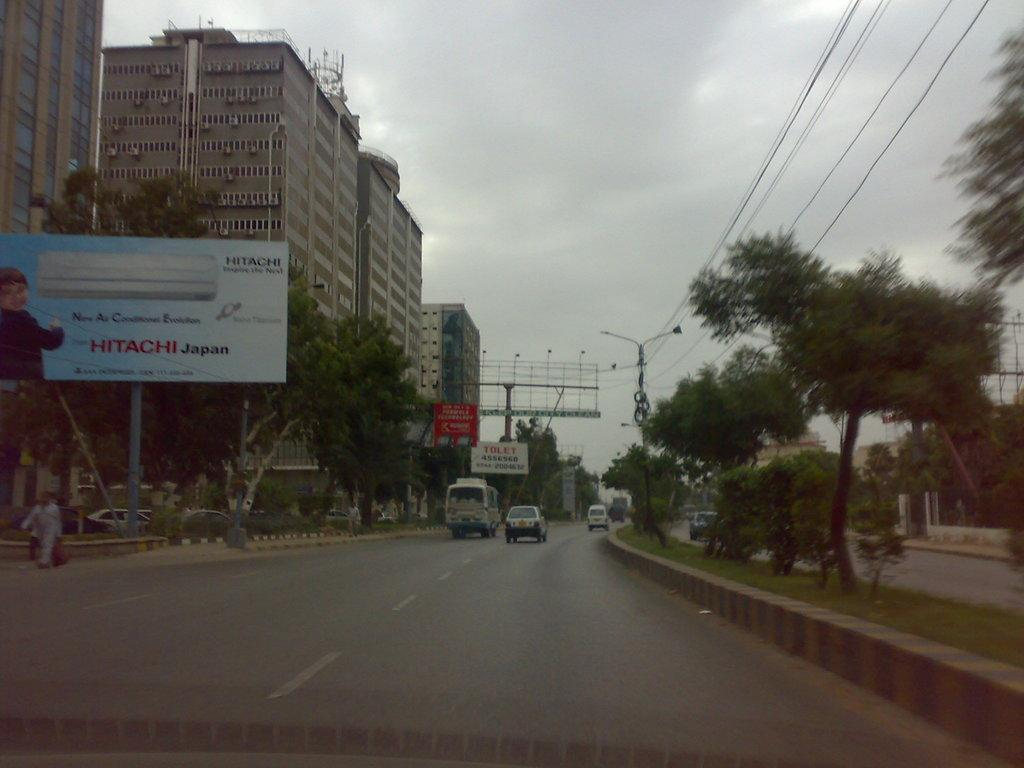Who or what can be seen in the image? There are people in the image. What else is present in the image besides people? There are vehicles in the image. Can you describe the left side of the image? There is a hoarding on the left side of the image. What can be seen in the background of the image? There are trees, buildings, poles, and cables in the background of the image. What type of pin is being used to hold the industry together in the image? There is no mention of an industry or a pin in the image; it features people and vehicles with a hoarding and background elements. 